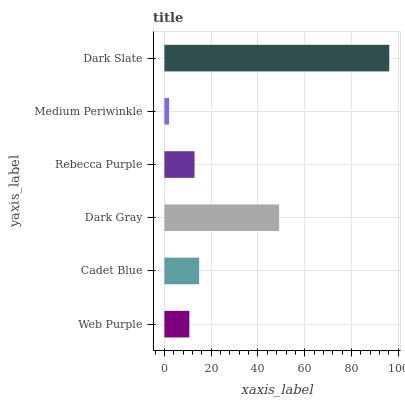Is Medium Periwinkle the minimum?
Answer yes or no. Yes. Is Dark Slate the maximum?
Answer yes or no. Yes. Is Cadet Blue the minimum?
Answer yes or no. No. Is Cadet Blue the maximum?
Answer yes or no. No. Is Cadet Blue greater than Web Purple?
Answer yes or no. Yes. Is Web Purple less than Cadet Blue?
Answer yes or no. Yes. Is Web Purple greater than Cadet Blue?
Answer yes or no. No. Is Cadet Blue less than Web Purple?
Answer yes or no. No. Is Cadet Blue the high median?
Answer yes or no. Yes. Is Rebecca Purple the low median?
Answer yes or no. Yes. Is Dark Gray the high median?
Answer yes or no. No. Is Dark Gray the low median?
Answer yes or no. No. 